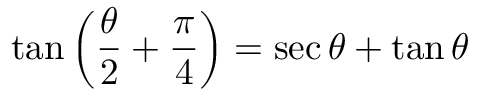<formula> <loc_0><loc_0><loc_500><loc_500>\tan \left ( { \frac { \theta } { 2 } } + { \frac { \pi } { 4 } } \right ) = \sec \theta + \tan \theta</formula> 